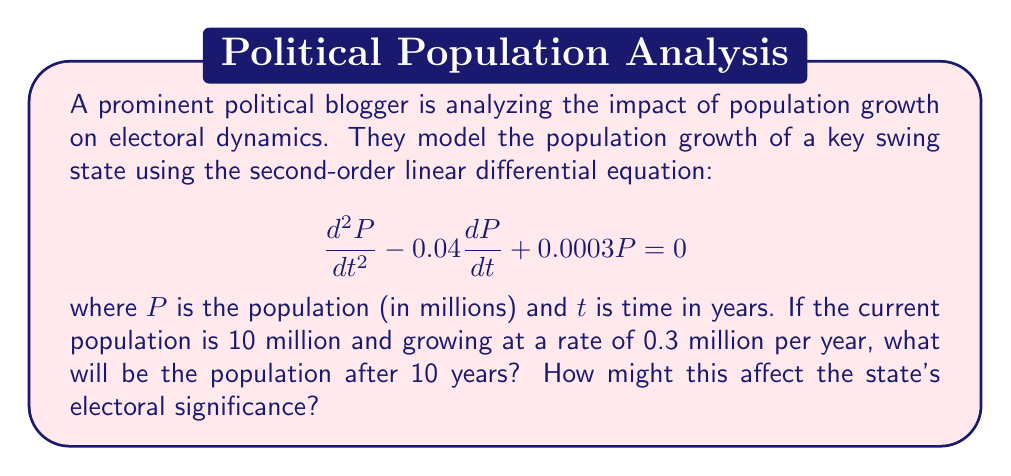Provide a solution to this math problem. To solve this problem, we need to follow these steps:

1) The general solution to this second-order linear differential equation is:

   $$P(t) = C_1e^{r_1t} + C_2e^{r_2t}$$

   where $r_1$ and $r_2$ are the roots of the characteristic equation:

   $$r^2 - 0.04r + 0.0003 = 0$$

2) Solving this quadratic equation:

   $$r = \frac{0.04 \pm \sqrt{0.04^2 - 4(0.0003)}}{2} = \frac{0.04 \pm \sqrt{0.0016 - 0.0012}}{2} = \frac{0.04 \pm 0.02}{2}$$

   So, $r_1 = 0.03$ and $r_2 = 0.01$

3) Therefore, the general solution is:

   $$P(t) = C_1e^{0.03t} + C_2e^{0.01t}$$

4) We can find $C_1$ and $C_2$ using the initial conditions:

   At $t=0$, $P(0) = 10$ and $P'(0) = 0.3$

5) From $P(0) = 10$:

   $$10 = C_1 + C_2$$

6) From $P'(0) = 0.3$:

   $$0.3 = 0.03C_1 + 0.01C_2$$

7) Solving these equations:

   $C_1 = 5$ and $C_2 = 5$

8) So, the particular solution is:

   $$P(t) = 5e^{0.03t} + 5e^{0.01t}$$

9) To find the population after 10 years, we calculate $P(10)$:

   $$P(10) = 5e^{0.3} + 5e^{0.1} \approx 13.82$$

Therefore, after 10 years, the population will be approximately 13.82 million.

This significant population growth of about 38% over 10 years could potentially increase the state's electoral significance, as it may lead to more electoral votes being allocated to this state in future redistributions.
Answer: The population after 10 years will be approximately 13.82 million. 